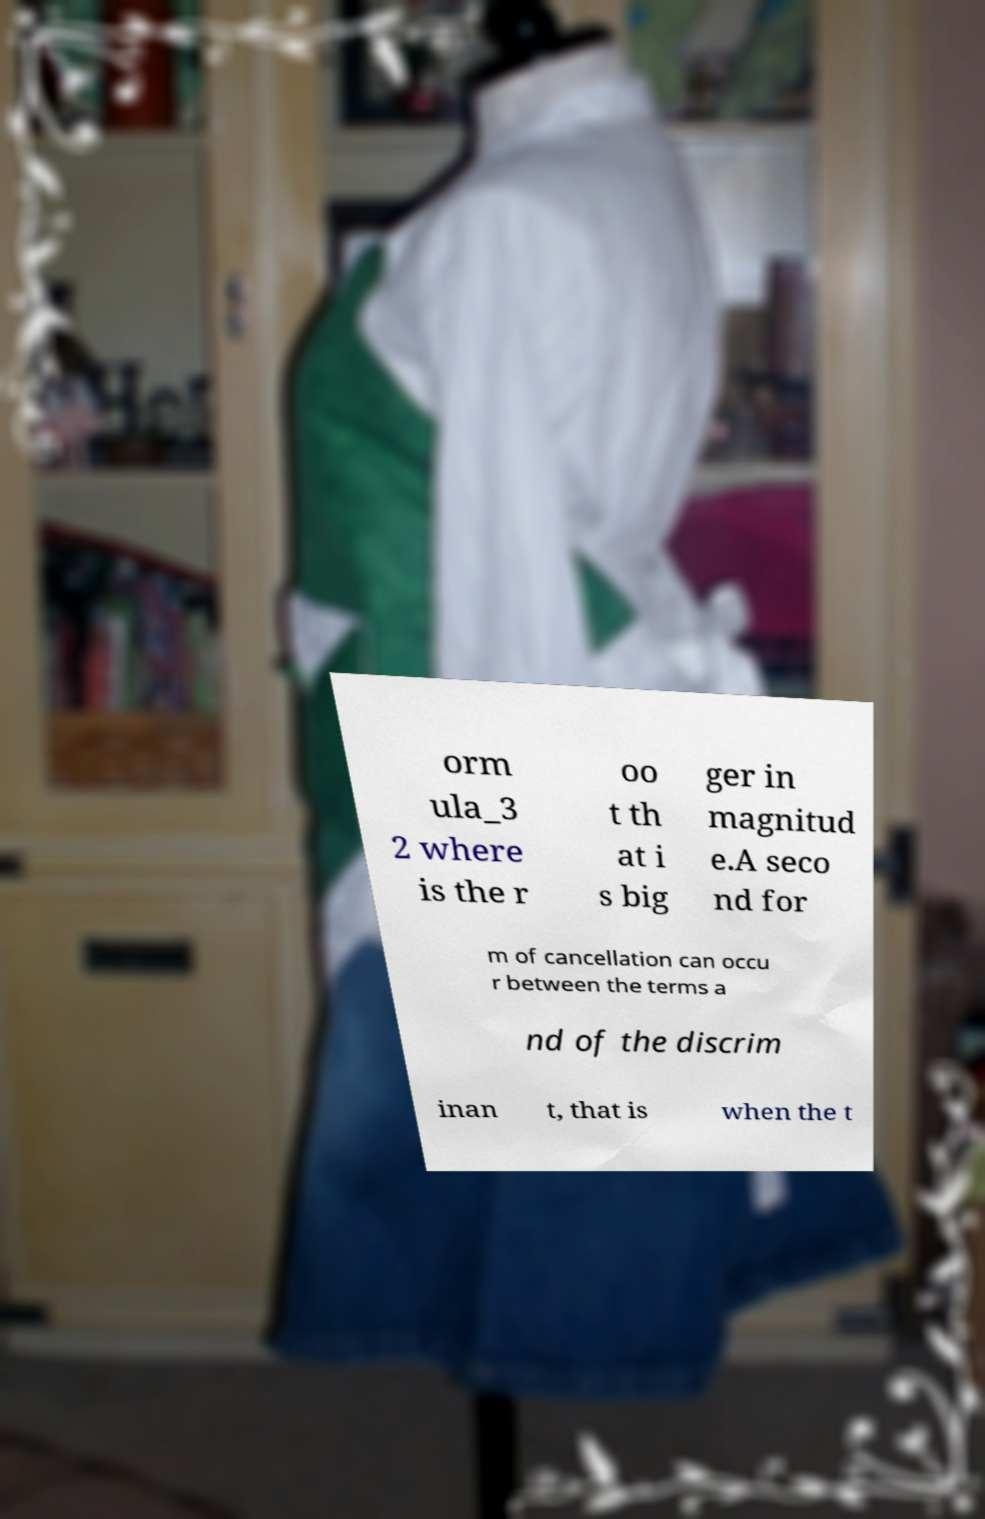Can you accurately transcribe the text from the provided image for me? orm ula_3 2 where is the r oo t th at i s big ger in magnitud e.A seco nd for m of cancellation can occu r between the terms a nd of the discrim inan t, that is when the t 